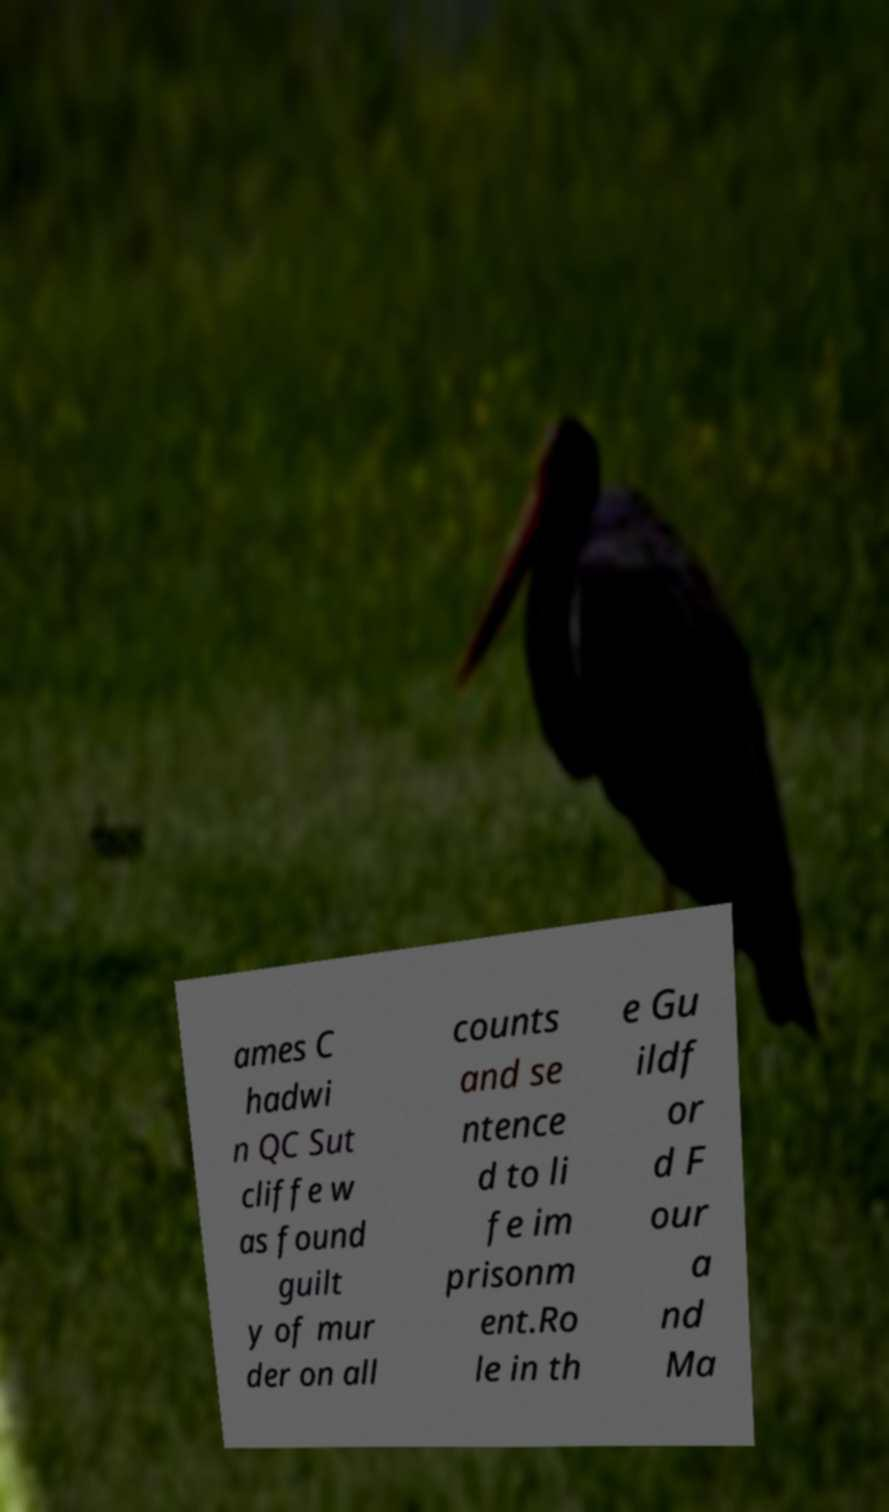Could you assist in decoding the text presented in this image and type it out clearly? ames C hadwi n QC Sut cliffe w as found guilt y of mur der on all counts and se ntence d to li fe im prisonm ent.Ro le in th e Gu ildf or d F our a nd Ma 